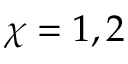Convert formula to latex. <formula><loc_0><loc_0><loc_500><loc_500>\chi = 1 , 2</formula> 